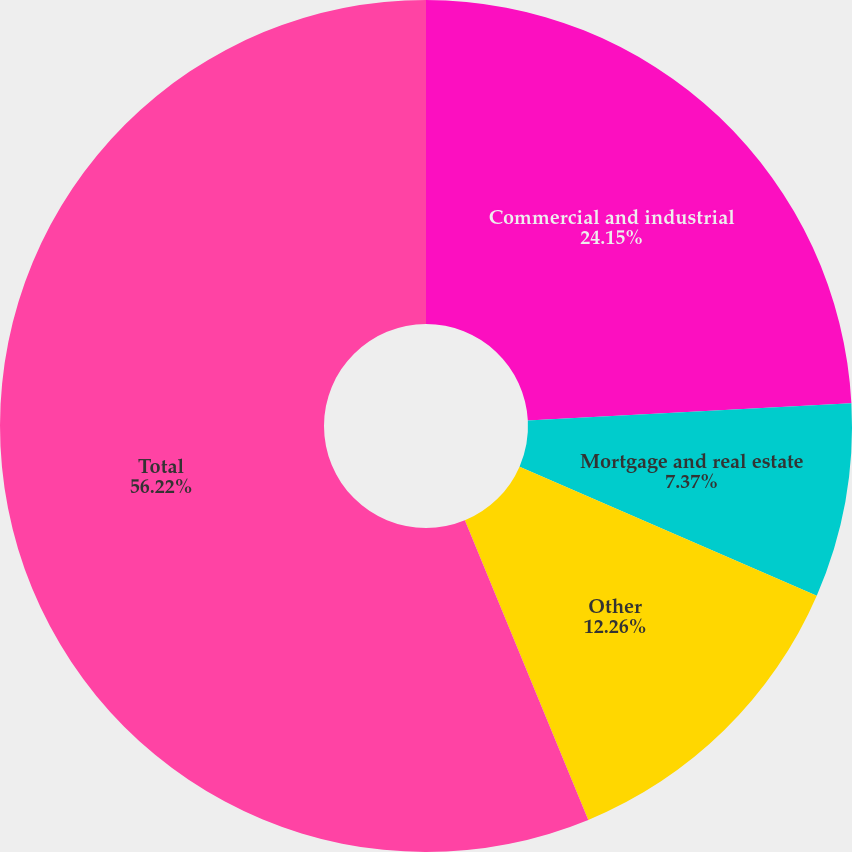<chart> <loc_0><loc_0><loc_500><loc_500><pie_chart><fcel>Commercial and industrial<fcel>Mortgage and real estate<fcel>Other<fcel>Total<nl><fcel>24.15%<fcel>7.37%<fcel>12.26%<fcel>56.22%<nl></chart> 